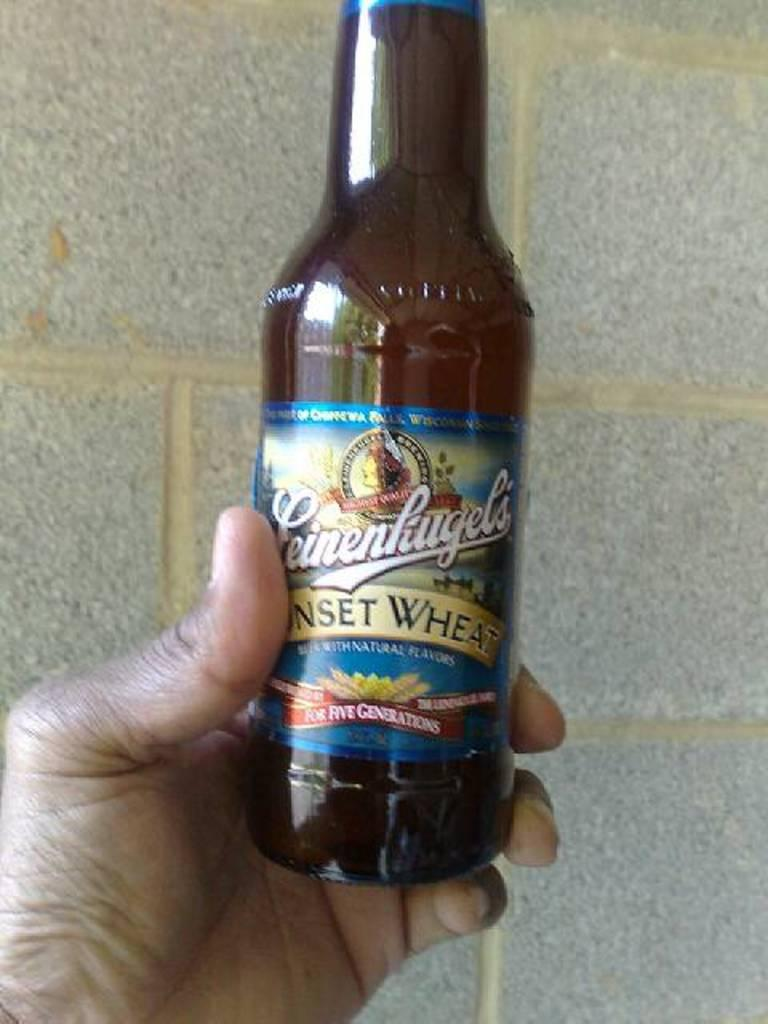<image>
Give a short and clear explanation of the subsequent image. a bottle of leinekugel's sunset wheat brewed beer 